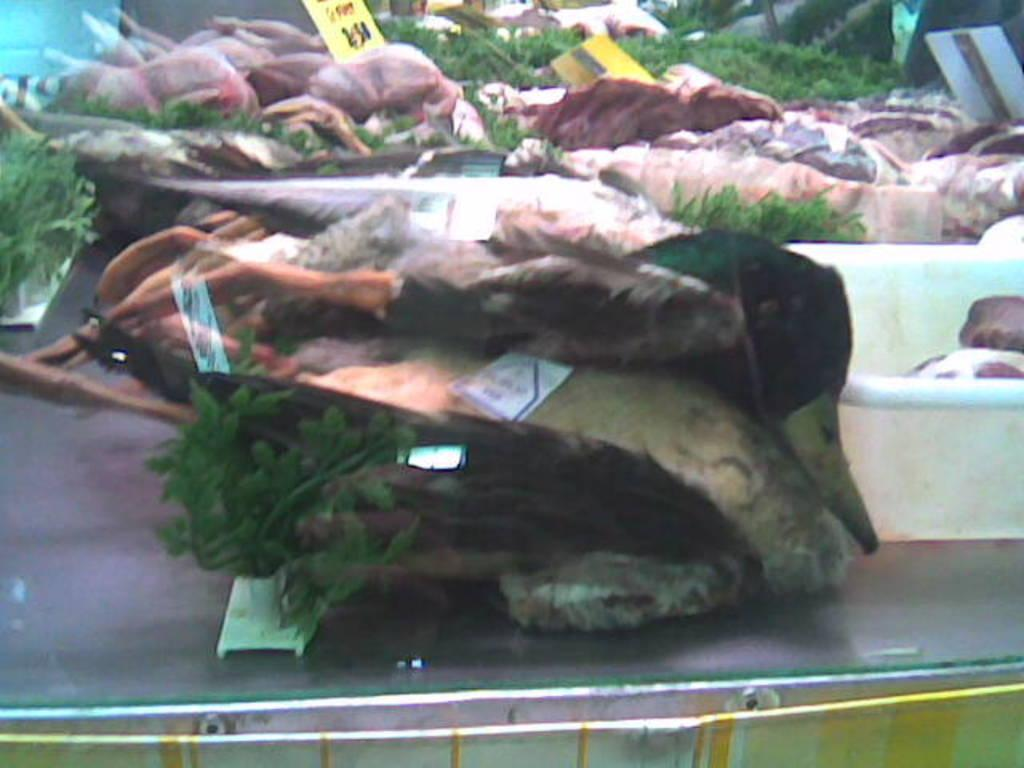What type of food is visible in the image? There is meat in the image. How can the price of the meat be determined? The meat has price tags in the image. What type of ball is being used to mine the meat in the image? There is no ball or mining activity present in the image; it features meat with price tags. What type of cable is connected to the meat in the image? There is no cable connected to the meat in the image. 